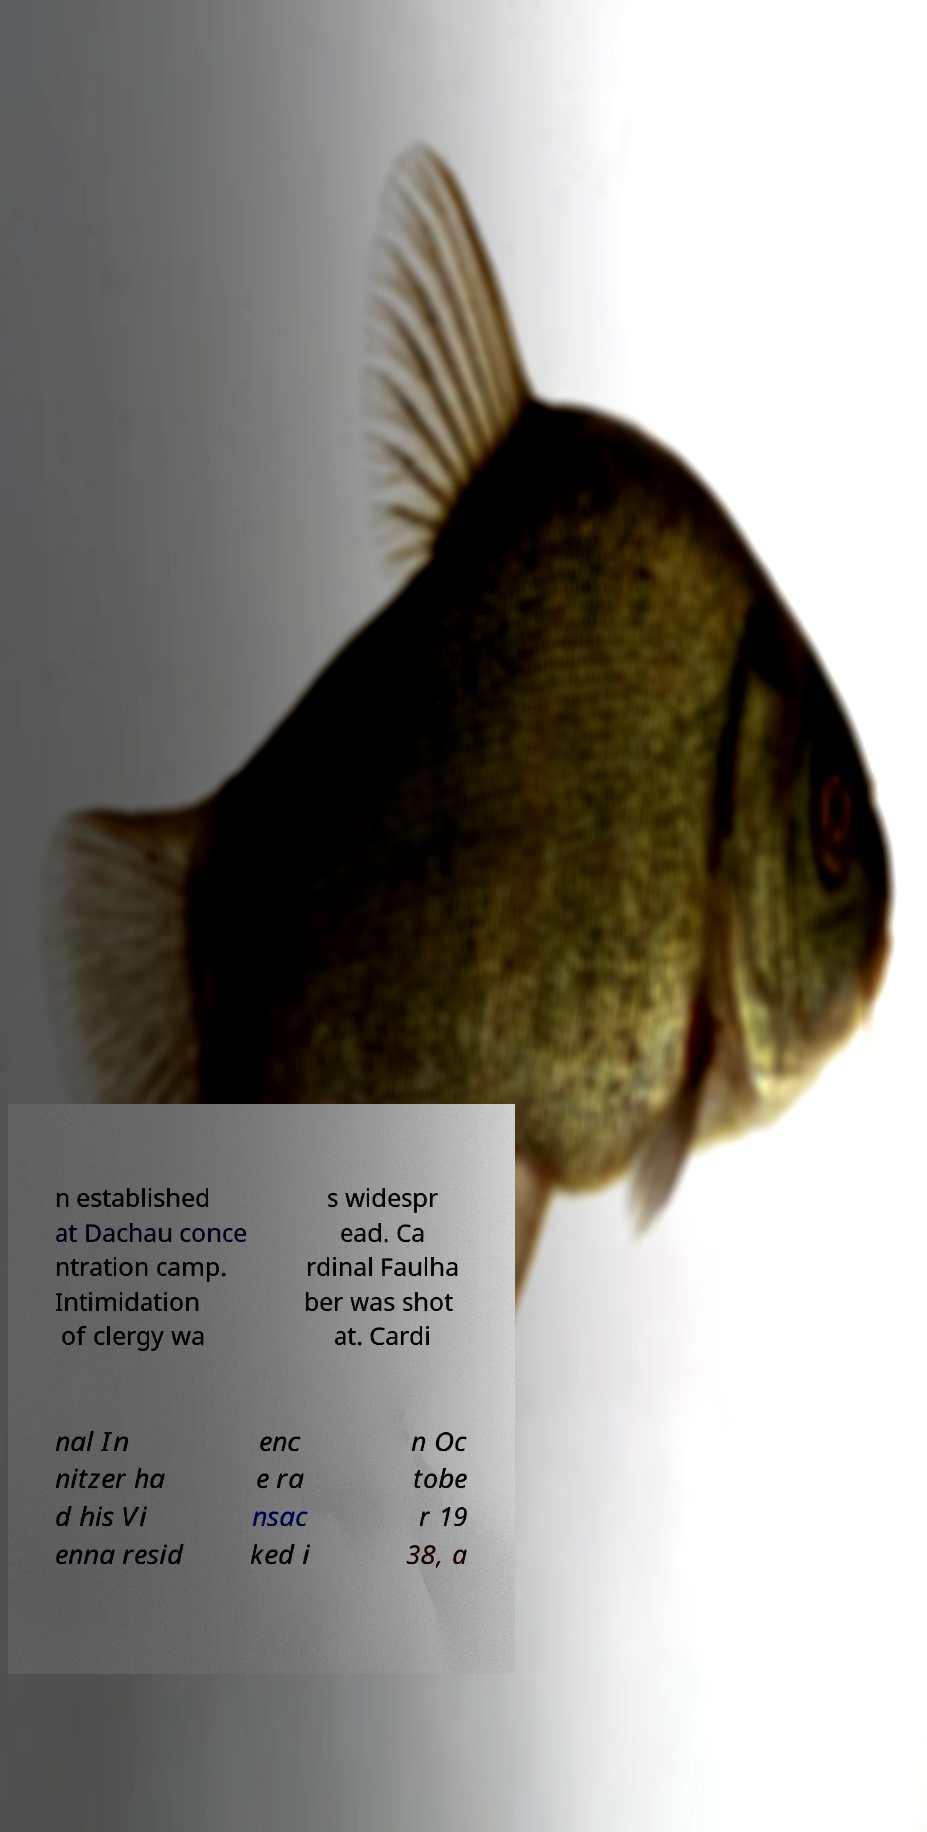Can you read and provide the text displayed in the image?This photo seems to have some interesting text. Can you extract and type it out for me? n established at Dachau conce ntration camp. Intimidation of clergy wa s widespr ead. Ca rdinal Faulha ber was shot at. Cardi nal In nitzer ha d his Vi enna resid enc e ra nsac ked i n Oc tobe r 19 38, a 